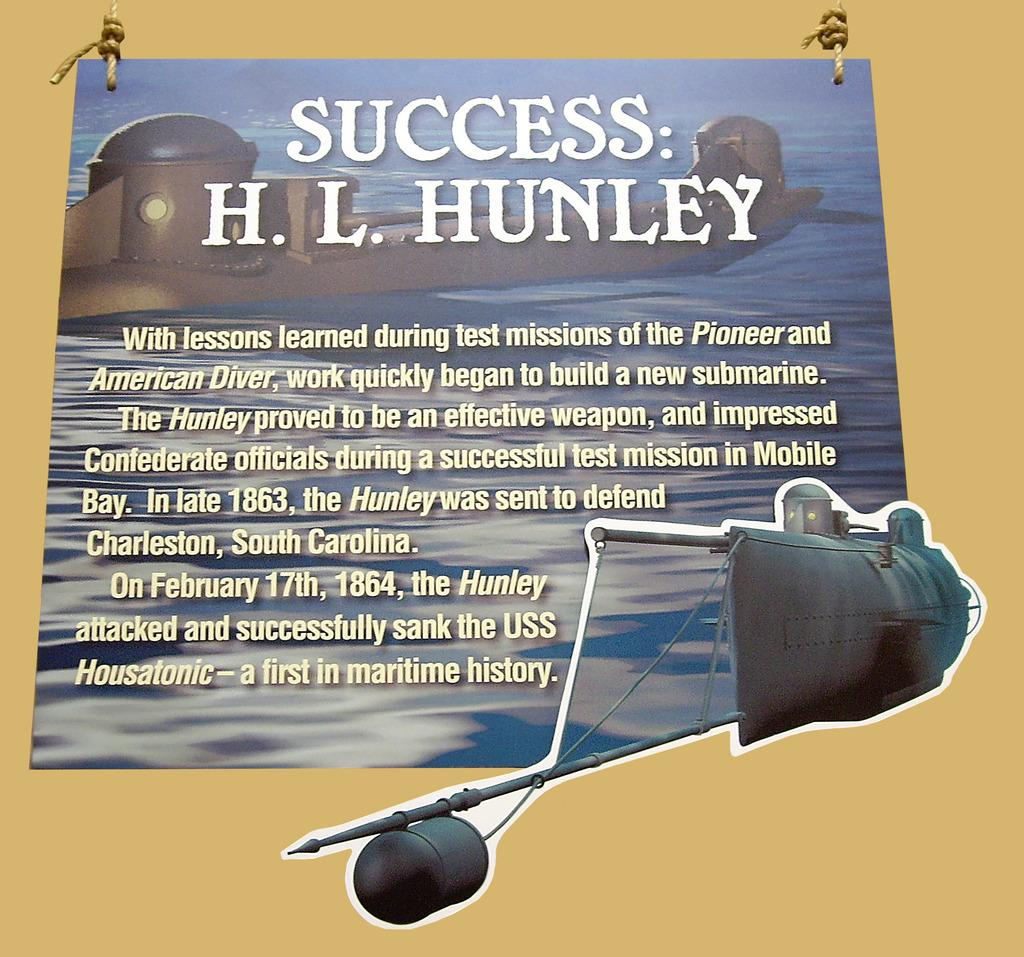<image>
Write a terse but informative summary of the picture. a poster on a yellow background with the title Success: H. L. Hunley 